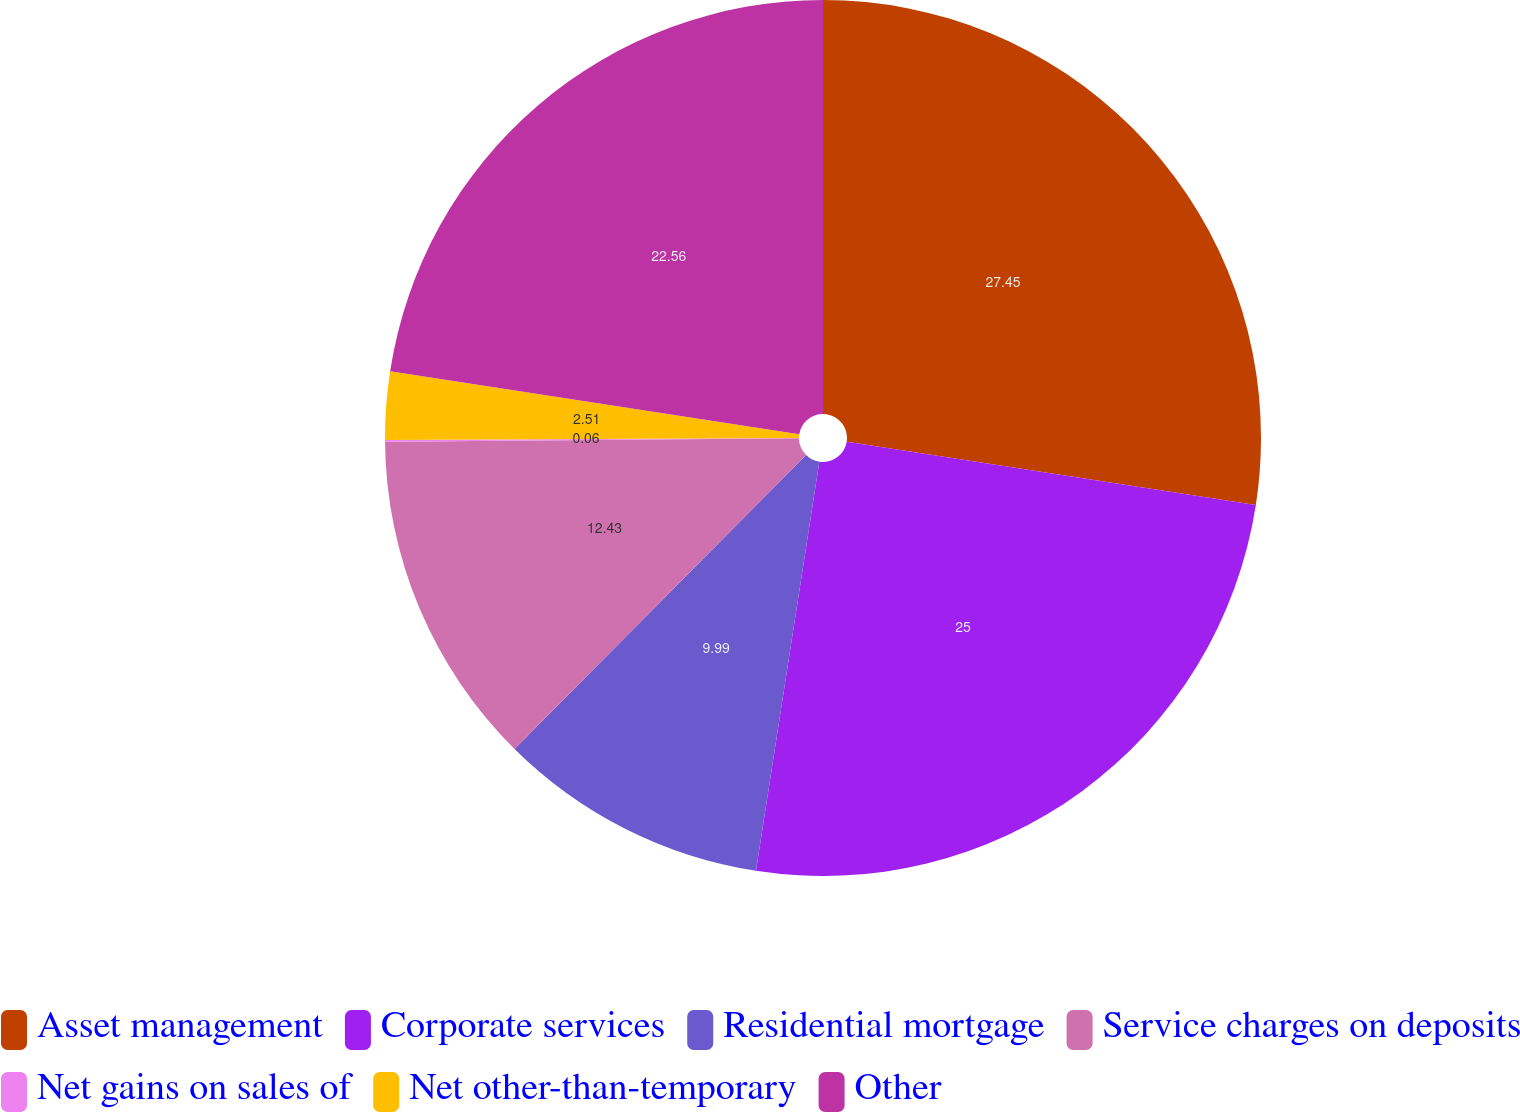Convert chart to OTSL. <chart><loc_0><loc_0><loc_500><loc_500><pie_chart><fcel>Asset management<fcel>Corporate services<fcel>Residential mortgage<fcel>Service charges on deposits<fcel>Net gains on sales of<fcel>Net other-than-temporary<fcel>Other<nl><fcel>27.44%<fcel>25.0%<fcel>9.99%<fcel>12.43%<fcel>0.06%<fcel>2.51%<fcel>22.56%<nl></chart> 